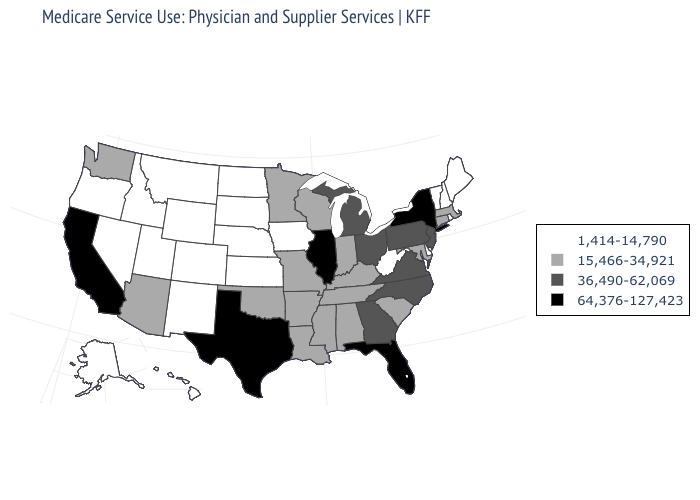Does Pennsylvania have the same value as Virginia?
Be succinct. Yes. How many symbols are there in the legend?
Answer briefly. 4. Does New York have the highest value in the Northeast?
Keep it brief. Yes. Does Michigan have the same value as Missouri?
Be succinct. No. Is the legend a continuous bar?
Quick response, please. No. What is the value of Minnesota?
Be succinct. 15,466-34,921. Among the states that border Oregon , does California have the highest value?
Give a very brief answer. Yes. What is the highest value in states that border Oklahoma?
Keep it brief. 64,376-127,423. Which states have the lowest value in the USA?
Write a very short answer. Alaska, Colorado, Delaware, Hawaii, Idaho, Iowa, Kansas, Maine, Montana, Nebraska, Nevada, New Hampshire, New Mexico, North Dakota, Oregon, Rhode Island, South Dakota, Utah, Vermont, West Virginia, Wyoming. Does Tennessee have the lowest value in the USA?
Short answer required. No. What is the lowest value in the South?
Give a very brief answer. 1,414-14,790. What is the value of Connecticut?
Answer briefly. 15,466-34,921. Does the first symbol in the legend represent the smallest category?
Give a very brief answer. Yes. Name the states that have a value in the range 64,376-127,423?
Short answer required. California, Florida, Illinois, New York, Texas. Does Illinois have the highest value in the MidWest?
Keep it brief. Yes. 